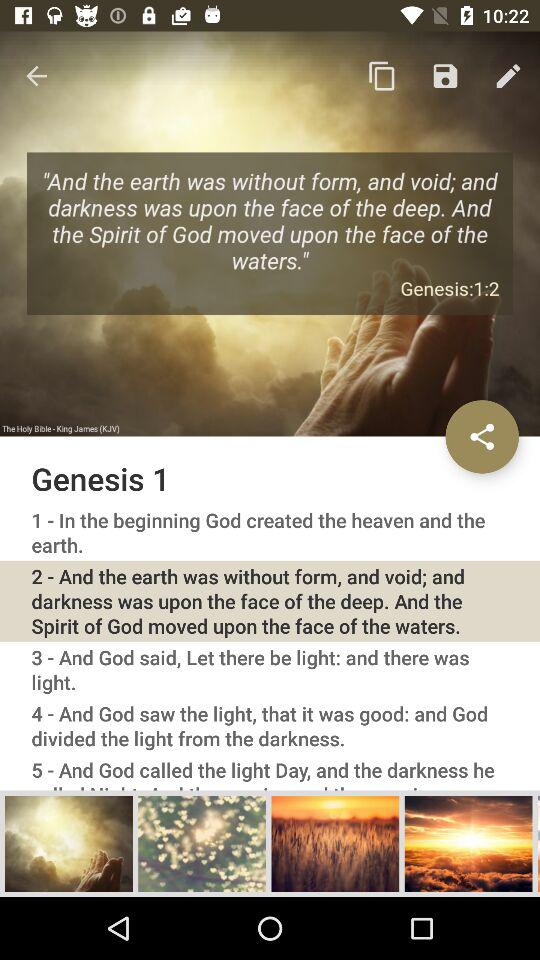What is the chapter name? The chapter name is "Genesis 1". 